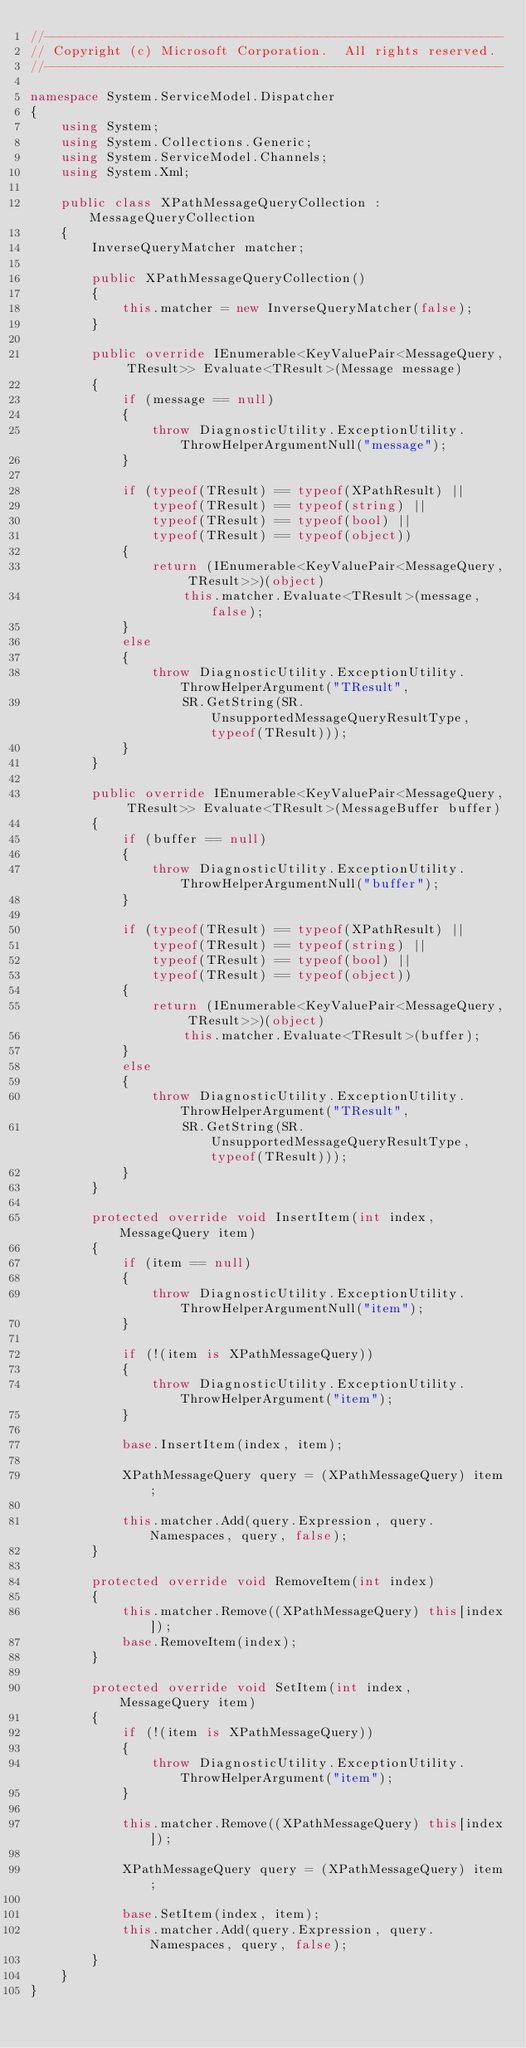<code> <loc_0><loc_0><loc_500><loc_500><_C#_>//------------------------------------------------------------
// Copyright (c) Microsoft Corporation.  All rights reserved.
//------------------------------------------------------------

namespace System.ServiceModel.Dispatcher
{
    using System;
    using System.Collections.Generic;
    using System.ServiceModel.Channels;
    using System.Xml;

    public class XPathMessageQueryCollection : MessageQueryCollection
    {
        InverseQueryMatcher matcher;

        public XPathMessageQueryCollection()
        {
            this.matcher = new InverseQueryMatcher(false);
        }

        public override IEnumerable<KeyValuePair<MessageQuery, TResult>> Evaluate<TResult>(Message message)
        {
            if (message == null)
            {
                throw DiagnosticUtility.ExceptionUtility.ThrowHelperArgumentNull("message");
            }

            if (typeof(TResult) == typeof(XPathResult) ||
                typeof(TResult) == typeof(string) ||
                typeof(TResult) == typeof(bool) ||
                typeof(TResult) == typeof(object))
            {
                return (IEnumerable<KeyValuePair<MessageQuery, TResult>>)(object)
                    this.matcher.Evaluate<TResult>(message, false);
            }
            else
            {
                throw DiagnosticUtility.ExceptionUtility.ThrowHelperArgument("TResult",
                    SR.GetString(SR.UnsupportedMessageQueryResultType, typeof(TResult)));
            }
        }

        public override IEnumerable<KeyValuePair<MessageQuery, TResult>> Evaluate<TResult>(MessageBuffer buffer)
        {
            if (buffer == null)
            {
                throw DiagnosticUtility.ExceptionUtility.ThrowHelperArgumentNull("buffer");
            }

            if (typeof(TResult) == typeof(XPathResult) ||
                typeof(TResult) == typeof(string) ||
                typeof(TResult) == typeof(bool) ||
                typeof(TResult) == typeof(object))
            {
                return (IEnumerable<KeyValuePair<MessageQuery, TResult>>)(object)
                    this.matcher.Evaluate<TResult>(buffer);
            }
            else
            {
                throw DiagnosticUtility.ExceptionUtility.ThrowHelperArgument("TResult",
                    SR.GetString(SR.UnsupportedMessageQueryResultType, typeof(TResult)));
            }
        }

        protected override void InsertItem(int index, MessageQuery item)
        {
            if (item == null)
            {
                throw DiagnosticUtility.ExceptionUtility.ThrowHelperArgumentNull("item");
            }

            if (!(item is XPathMessageQuery))
            {
                throw DiagnosticUtility.ExceptionUtility.ThrowHelperArgument("item");
            }

            base.InsertItem(index, item);

            XPathMessageQuery query = (XPathMessageQuery) item;

            this.matcher.Add(query.Expression, query.Namespaces, query, false);
        }

        protected override void RemoveItem(int index)
        {
            this.matcher.Remove((XPathMessageQuery) this[index]);
            base.RemoveItem(index);
        }

        protected override void SetItem(int index, MessageQuery item)
        {
            if (!(item is XPathMessageQuery))
            {
                throw DiagnosticUtility.ExceptionUtility.ThrowHelperArgument("item");
            }

            this.matcher.Remove((XPathMessageQuery) this[index]);

            XPathMessageQuery query = (XPathMessageQuery) item;

            base.SetItem(index, item);
            this.matcher.Add(query.Expression, query.Namespaces, query, false);
        }
    }
}
</code> 